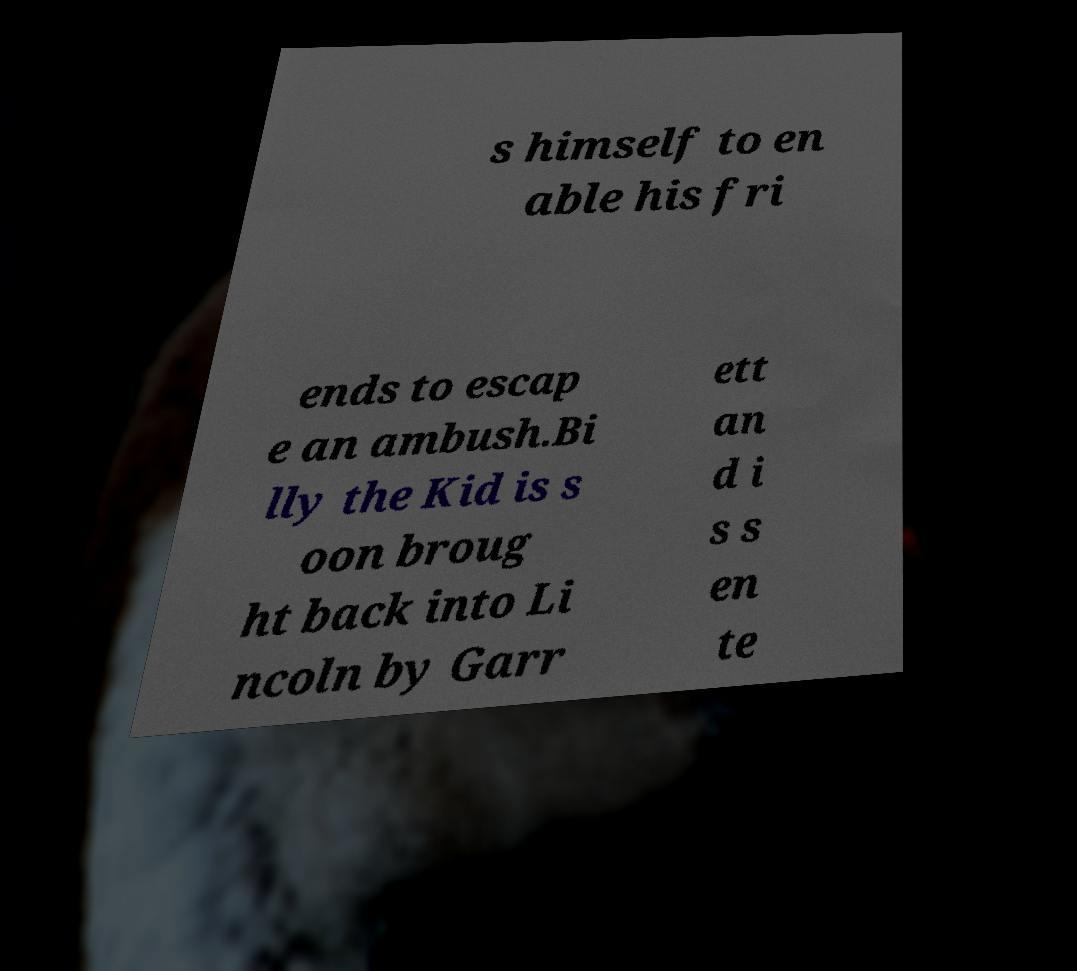I need the written content from this picture converted into text. Can you do that? s himself to en able his fri ends to escap e an ambush.Bi lly the Kid is s oon broug ht back into Li ncoln by Garr ett an d i s s en te 